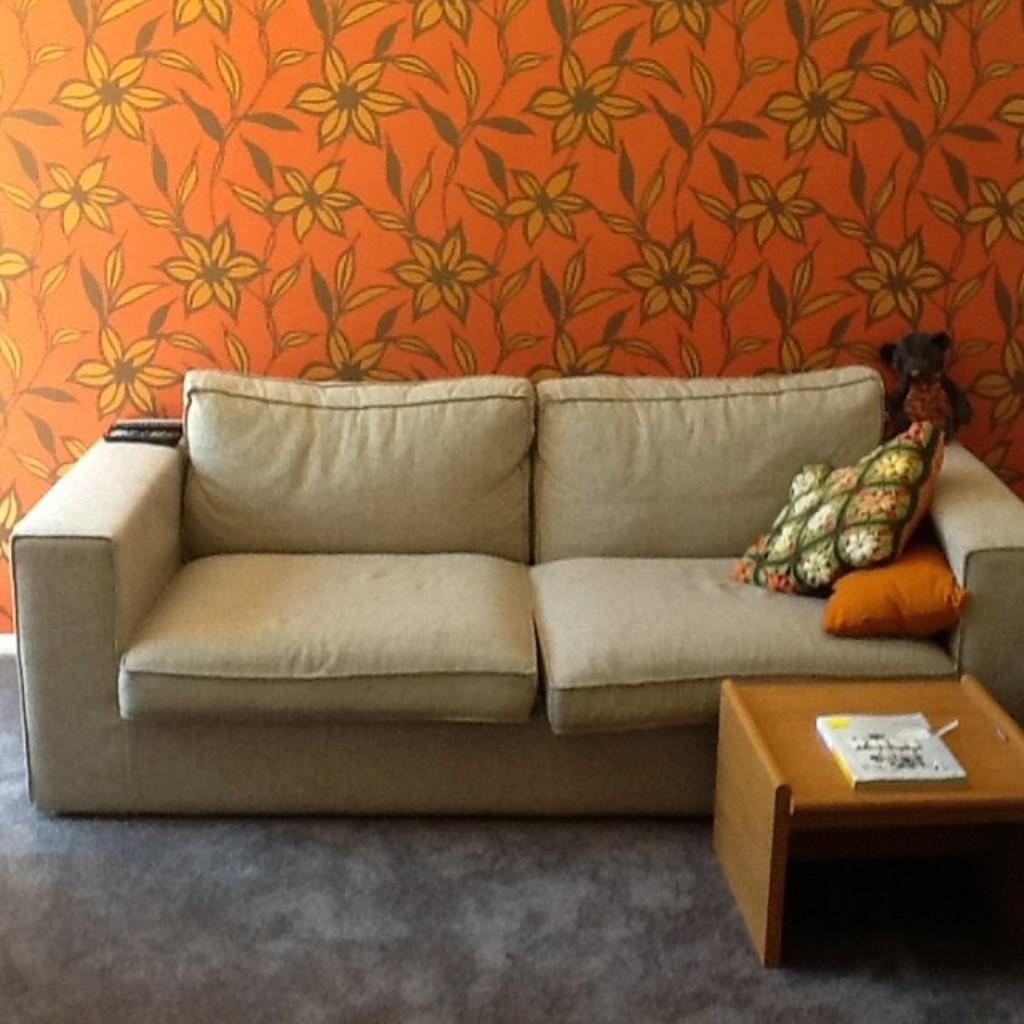What type of structure can be seen in the image? There is a wall in the image. What type of furniture is present in the image? There is a sofa in the image. What type of accessory is present on the sofa? There are pillows in the image. Can you see any docks or mountains in the image? No, there are no docks or mountains present in the image. How many cars can be seen in the image? There are no cars present in the image. 